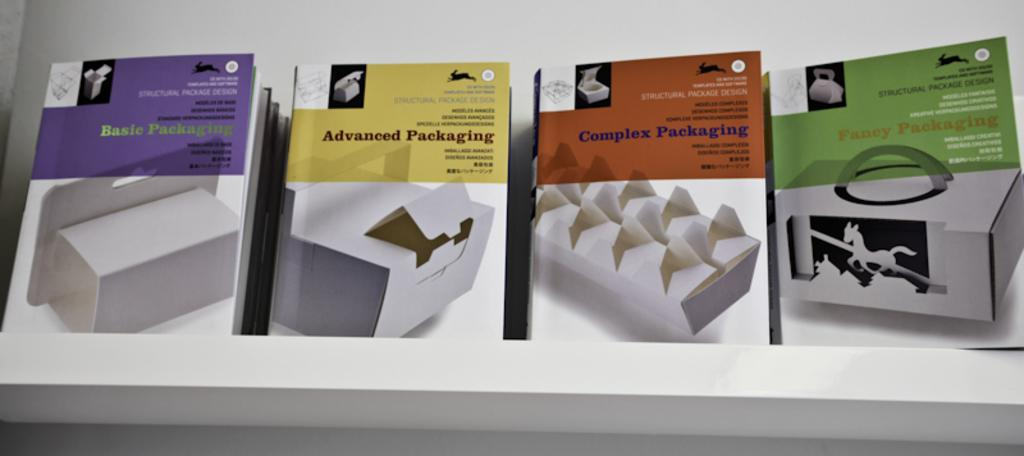<image>
Render a clear and concise summary of the photo. four books on a shelf with the title Packaging 